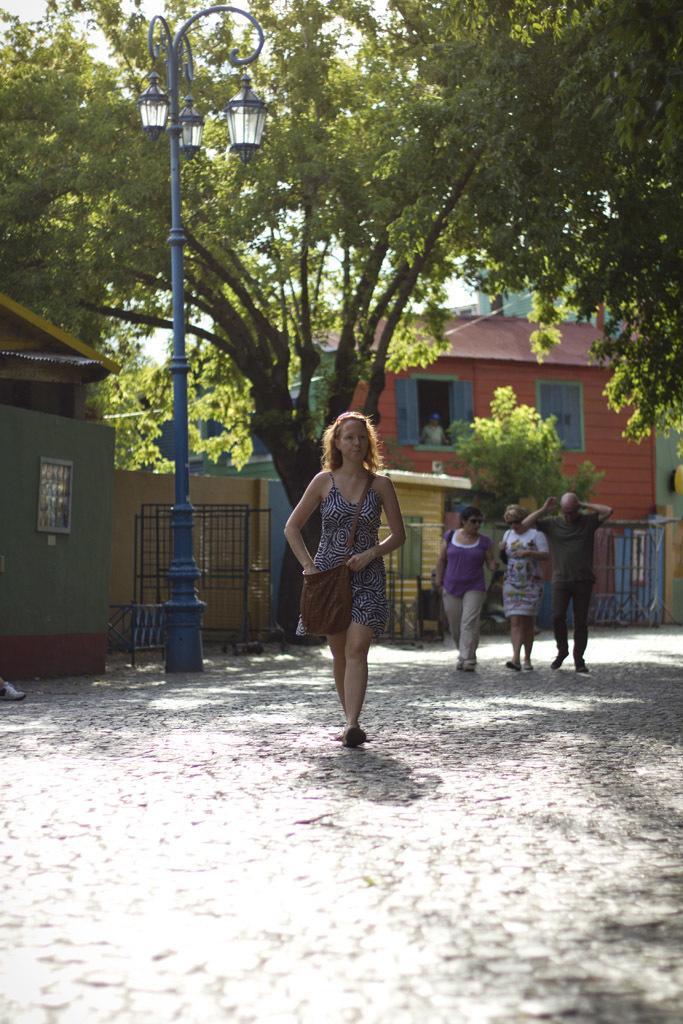Describe this image in one or two sentences. In the middle of this image, there is a woman, wearing a bag and walking on the road. Behind her, there are two women and a man walking on the road, there are lights attached to a pole, there are fences and trees. In the background, there are buildings and there are clouds in the sky. 